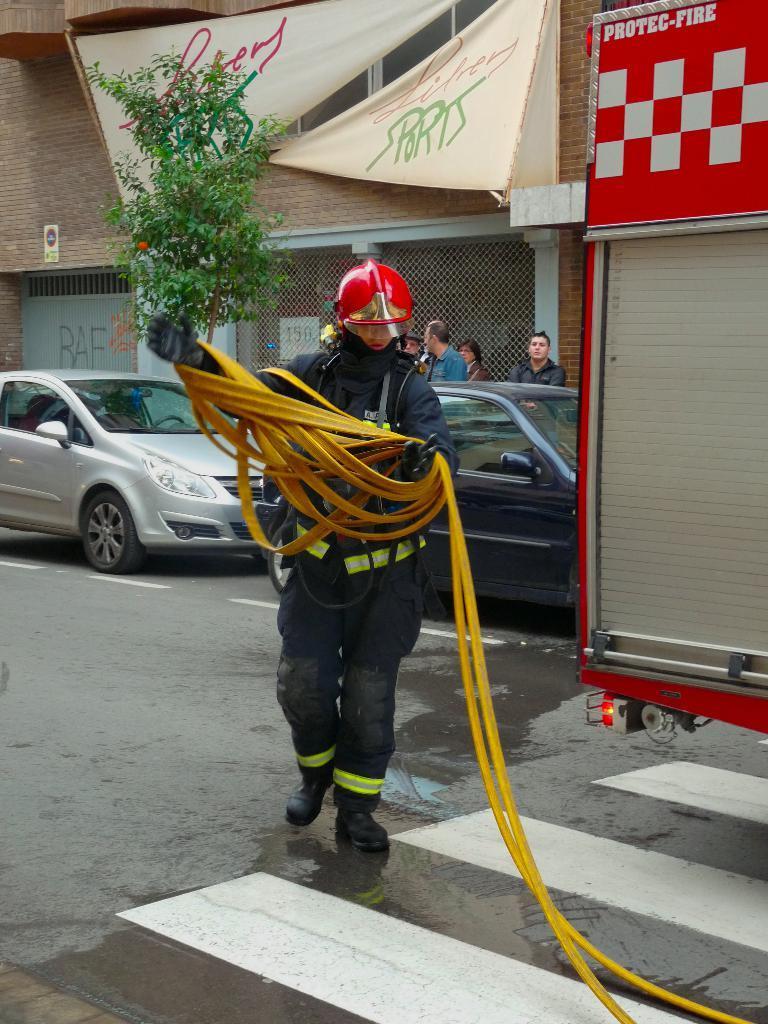Describe this image in one or two sentences. In the image in the center we can see one person standing and holding yellow color object and wearing red color helmet. In the background there is a building,wall,tree,fence,sign board,banners,vehicles and few people were standing. 